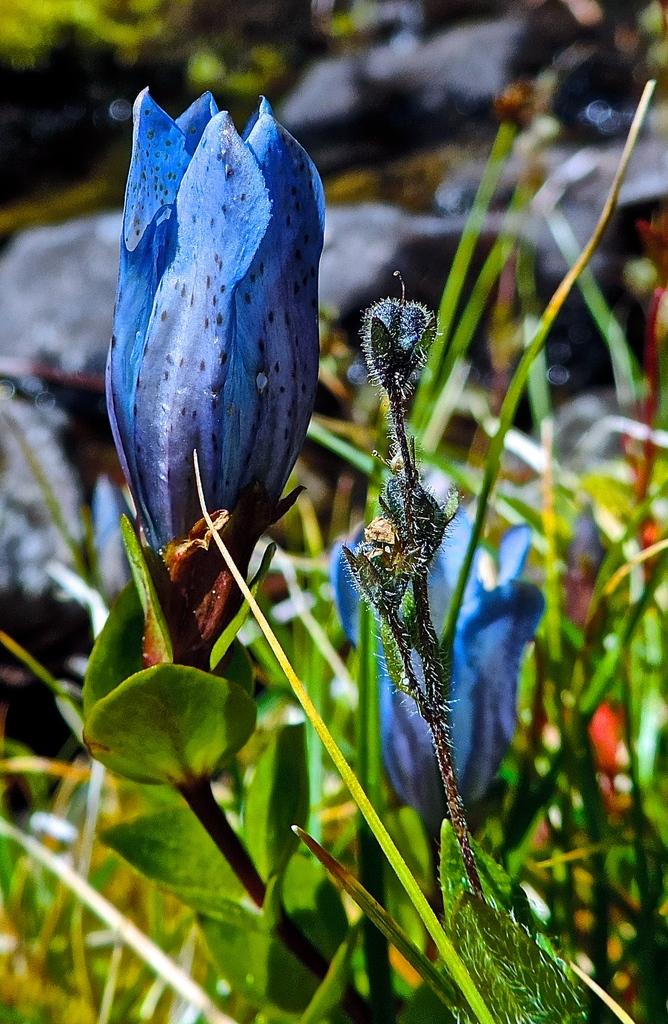What is the main subject in the foreground of the image? There is a flower in the foreground of the image. What is the current state of the flower in the image? There are buds on the plant in the foreground. What type of vegetation can be seen in the background of the image? There is greenery in the background of the image. What purpose does the note serve in the image? There is no note present in the image. 